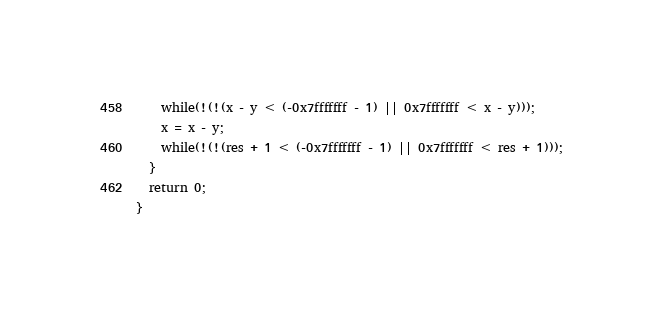<code> <loc_0><loc_0><loc_500><loc_500><_C_>    while(!(!(x - y < (-0x7fffffff - 1) || 0x7fffffff < x - y)));
    x = x - y;
    while(!(!(res + 1 < (-0x7fffffff - 1) || 0x7fffffff < res + 1)));
  }
  return 0;
}
</code> 